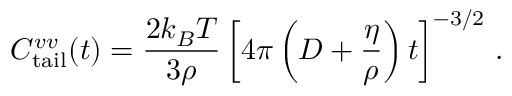Convert formula to latex. <formula><loc_0><loc_0><loc_500><loc_500>C _ { t a i l } ^ { v v } ( t ) = \frac { 2 k _ { B } T } { 3 \rho } \left [ 4 \pi \left ( D + \frac { \eta } { \rho } \right ) t \right ] ^ { - 3 / 2 } \, .</formula> 